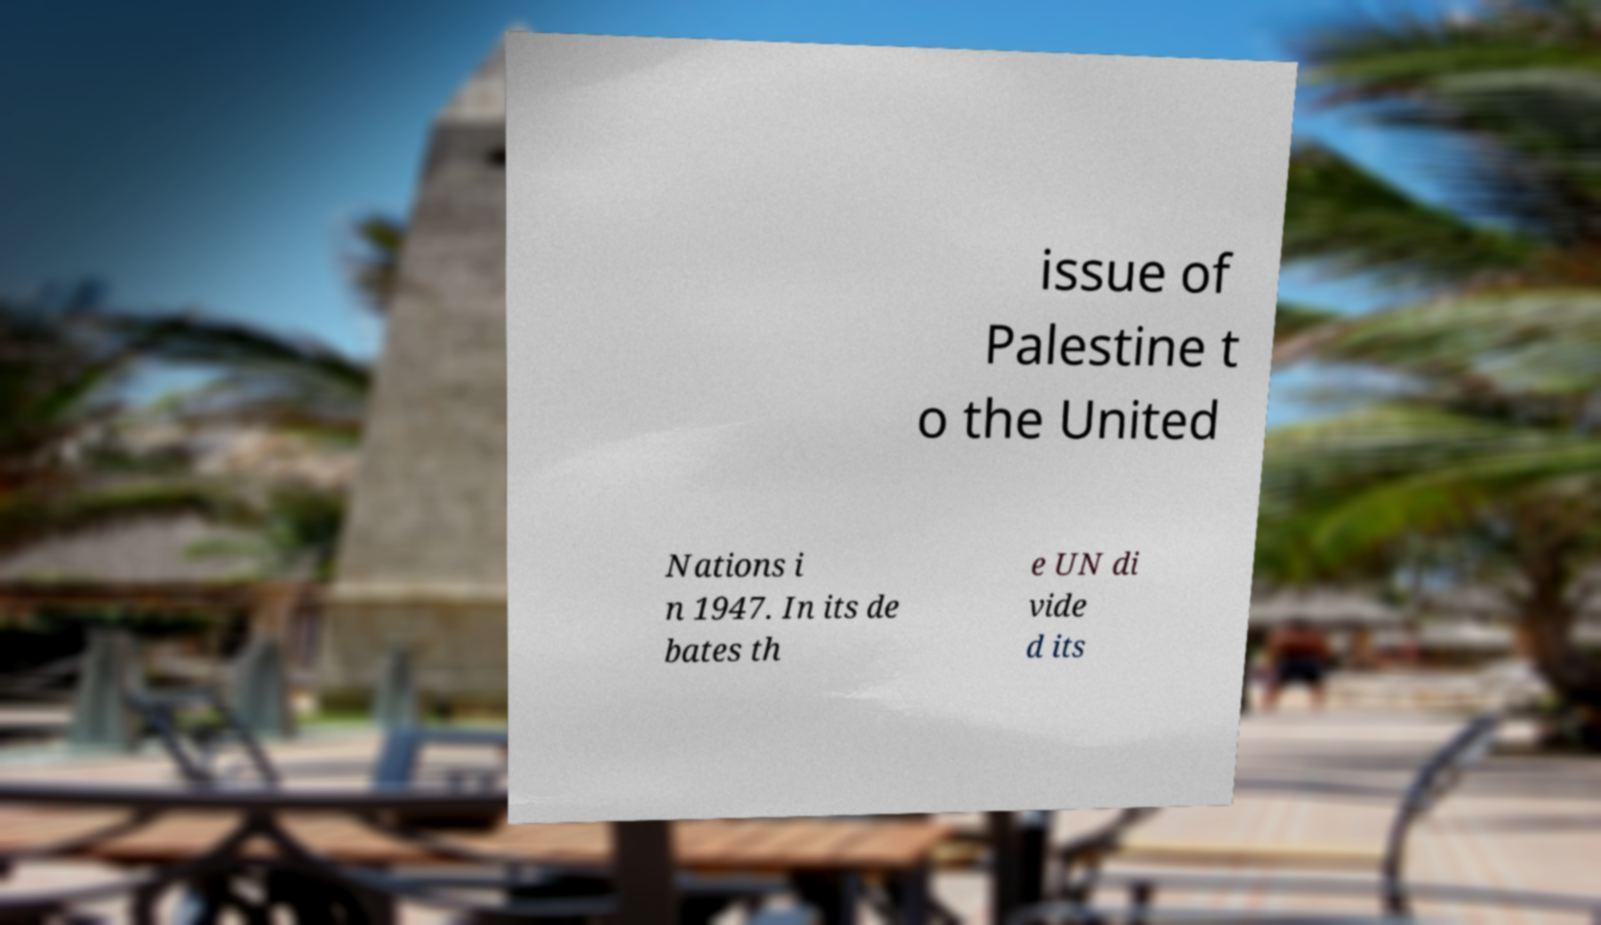Can you read and provide the text displayed in the image?This photo seems to have some interesting text. Can you extract and type it out for me? issue of Palestine t o the United Nations i n 1947. In its de bates th e UN di vide d its 